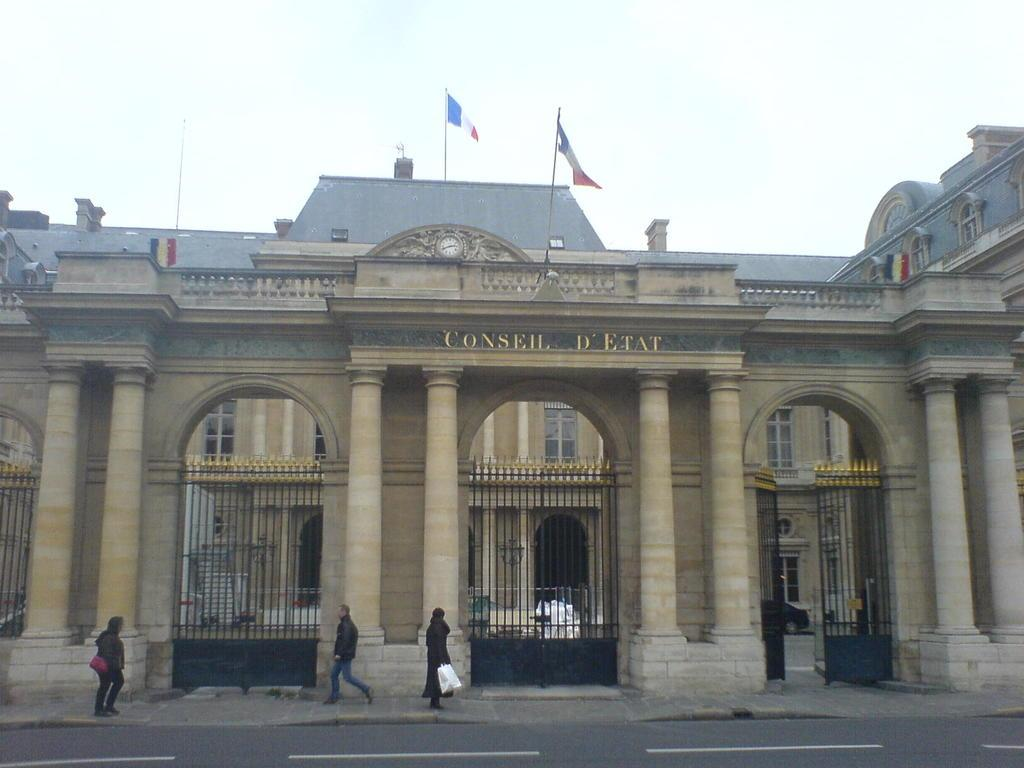What type of structure is present in the image? There is an entrance wall in the image. What feature does the entrance wall have? The entrance wall has an arch. How many gates are associated with the entrance wall? There are four gates associated with the entrance wall. What is happening in front of the entrance wall? People are walking in front of the wall. What can be seen in the background of the image? There is a building and flags in the background of the image, and the sky is visible. What type of writing can be seen on the pear in the image? There is no pear present in the image, and therefore no writing can be observed on it. 